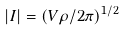<formula> <loc_0><loc_0><loc_500><loc_500>| I | = ( V \rho / 2 \pi ) ^ { 1 / 2 }</formula> 